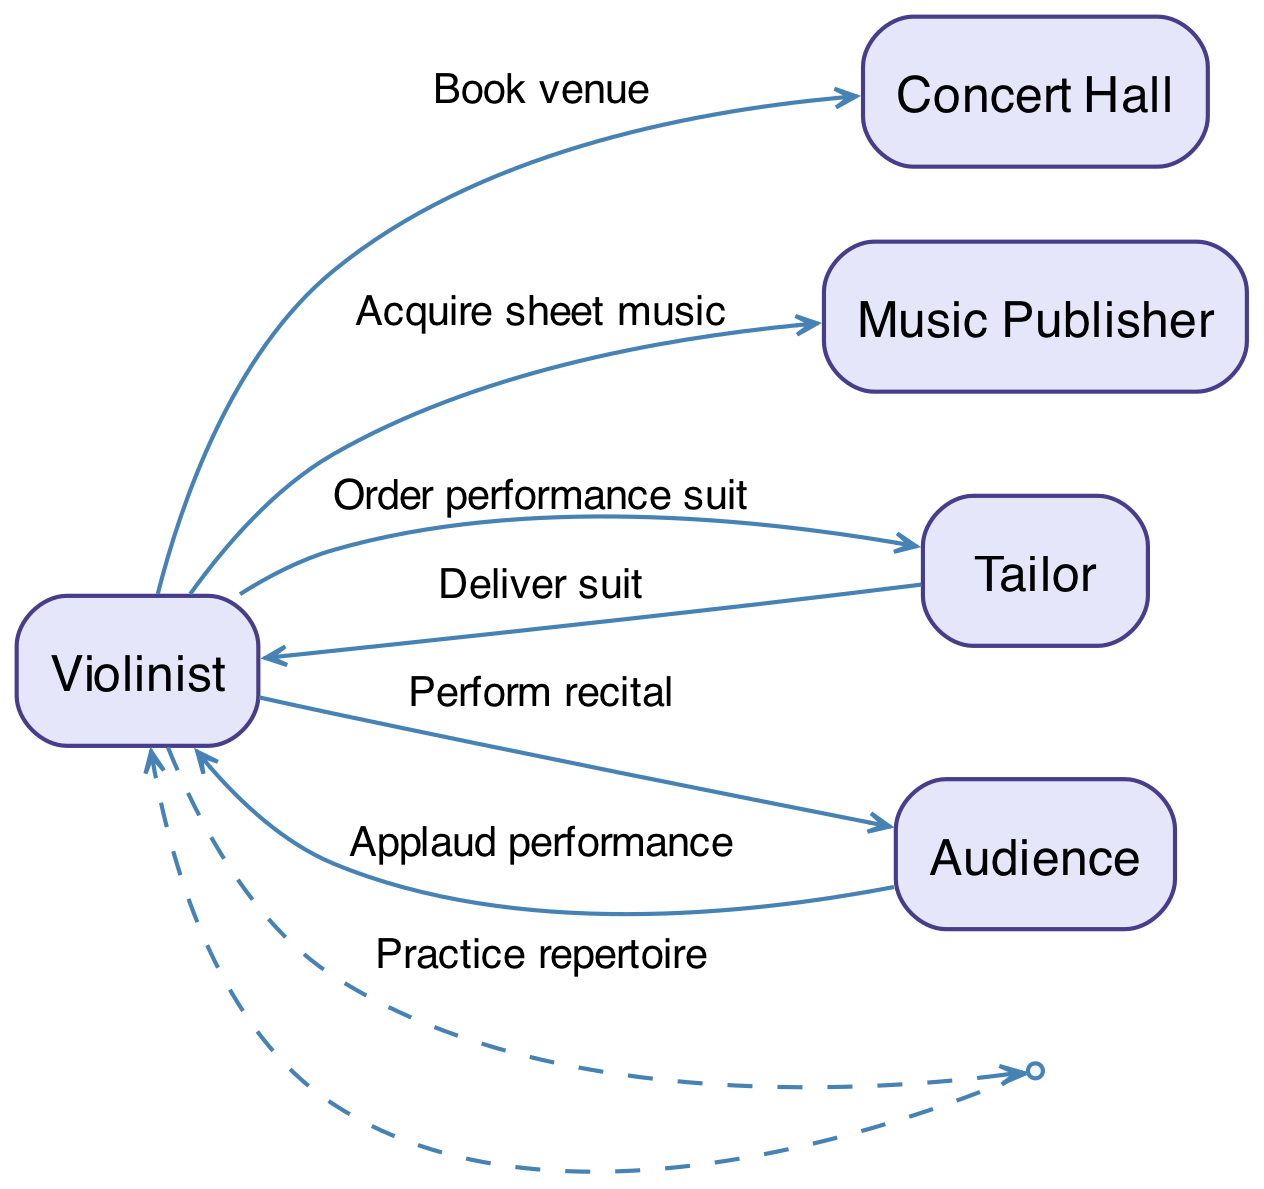What is the first action taken by the Violinist? The first action taken by the Violinist in the sequence is "Book venue," which shows the initial step in planning the solo recital.
Answer: Book venue How many total actors are involved in this sequence? The sequence diagram includes five actors: Violinist, Concert Hall, Music Publisher, Tailor, and Audience, which represents all entities involved in the workflow.
Answer: 5 What action does the Tailor perform in the sequence? The action taken by the Tailor is "Deliver suit," which completes the interaction between the Tailor and the Violinist concerning the performance attire.
Answer: Deliver suit What is the last action noted in the sequence? The last action in the sequence is "Applaud performance," indicating the audience's response after the recital has been performed by the Violinist.
Answer: Applaud performance Who does the Violinist perform the recital for? The Violinist performs the recital for the Audience, which is the final interaction shown in the sequence of events.
Answer: Audience What action comes after the Violinist practices the repertoire? After the practice of the repertoire, the subsequent action is the "Deliver suit" from the Tailor to the Violinist, indicating preparation for the performance.
Answer: Deliver suit Which actor interacts with the Violinist to acquire sheet music? The Music Publisher is the actor involved in the interaction with the Violinist to "Acquire sheet music," crucial for the recital setup.
Answer: Music Publisher What is the relationship between the Violinist and the Concert Hall? The relationship is that the Violinist books the venue (Concert Hall), establishing a connection between the performer and the location of the recital.
Answer: Book venue What is the intermediate action for the Violinist before the recital? The intermediate action is "Order performance suit," which refers to the preparation stage before the actual performance can take place.
Answer: Order performance suit 